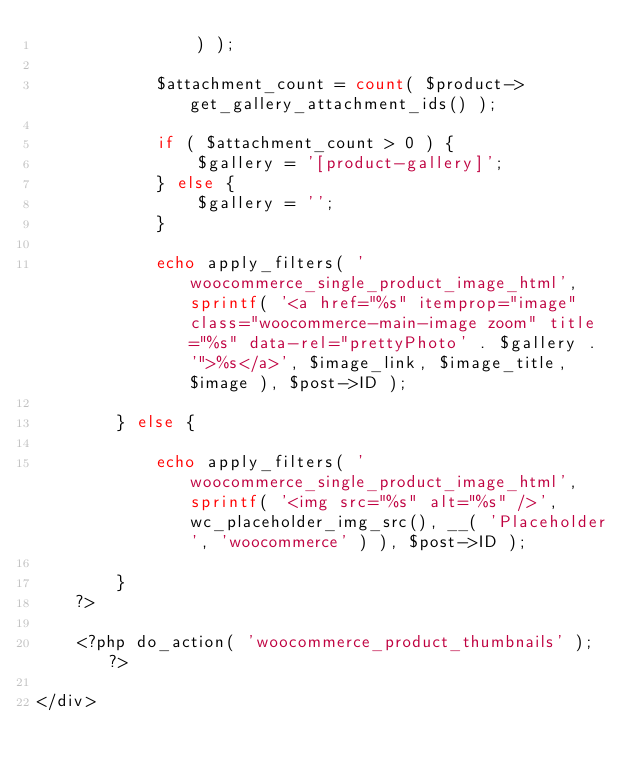<code> <loc_0><loc_0><loc_500><loc_500><_PHP_>				) );

			$attachment_count = count( $product->get_gallery_attachment_ids() );

			if ( $attachment_count > 0 ) {
				$gallery = '[product-gallery]';
			} else {
				$gallery = '';
			}

			echo apply_filters( 'woocommerce_single_product_image_html', sprintf( '<a href="%s" itemprop="image" class="woocommerce-main-image zoom" title="%s" data-rel="prettyPhoto' . $gallery . '">%s</a>', $image_link, $image_title, $image ), $post->ID );

		} else {

			echo apply_filters( 'woocommerce_single_product_image_html', sprintf( '<img src="%s" alt="%s" />', wc_placeholder_img_src(), __( 'Placeholder', 'woocommerce' ) ), $post->ID );

		}
	?>

	<?php do_action( 'woocommerce_product_thumbnails' ); ?>

</div>
</code> 